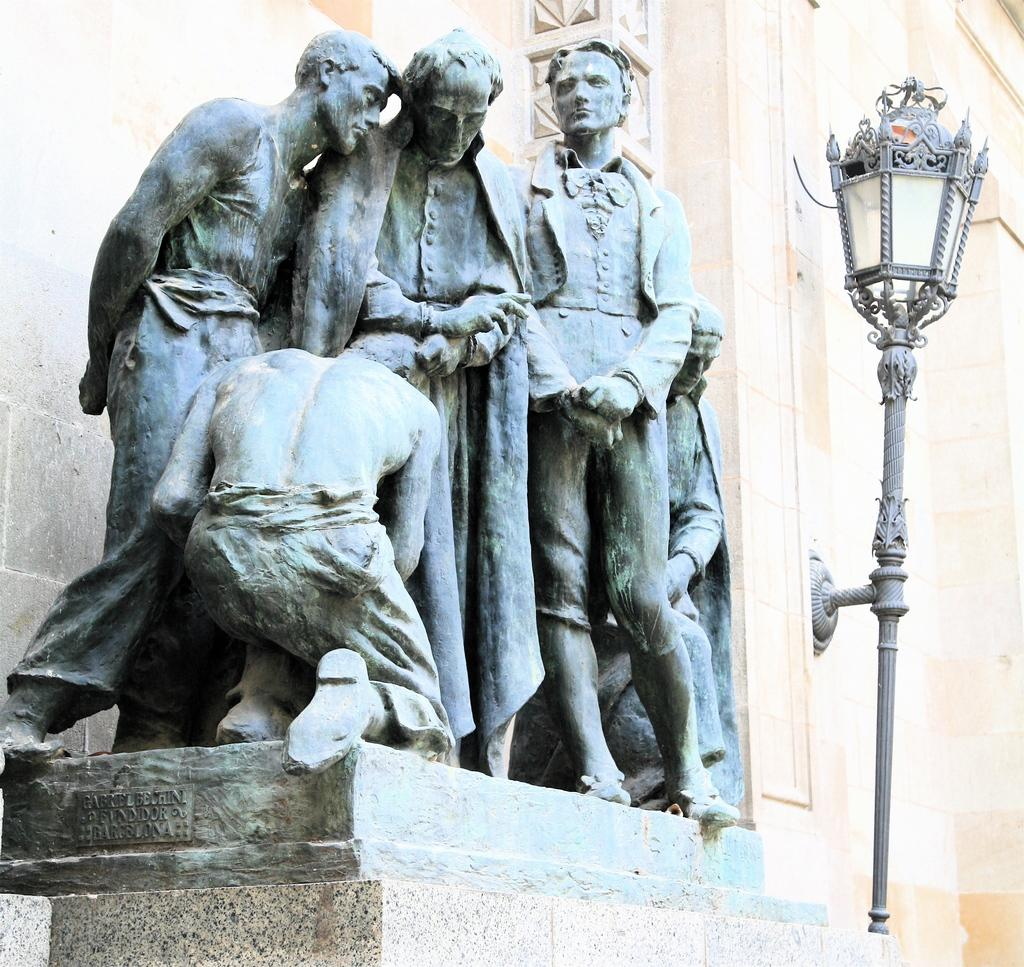What is the main subject in the center of the image? There is a sculpture in the center of the image. What can be seen on the right side of the image? There is a street light on the right side of the image. What is visible in the background of the image? There is a building wall in the background of the image. What type of substance is leaking from the drain in the image? There is no drain present in the image, so it is not possible to determine if any substance is leaking. 